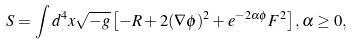<formula> <loc_0><loc_0><loc_500><loc_500>S = \int d ^ { 4 } x \sqrt { - g } \left [ - R + 2 ( \nabla \phi ) ^ { 2 } + e ^ { - 2 \alpha \phi } F ^ { 2 } \right ] , \alpha \geq 0 ,</formula> 